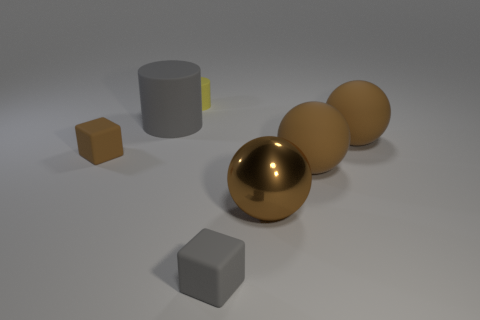Subtract all large brown metal balls. How many balls are left? 2 Add 2 small gray cylinders. How many objects exist? 9 Subtract all spheres. How many objects are left? 4 Subtract 2 blocks. How many blocks are left? 0 Subtract 0 green spheres. How many objects are left? 7 Subtract all purple cylinders. Subtract all cyan blocks. How many cylinders are left? 2 Subtract all large shiny cylinders. Subtract all brown things. How many objects are left? 3 Add 2 gray objects. How many gray objects are left? 4 Add 2 small cyan rubber cylinders. How many small cyan rubber cylinders exist? 2 